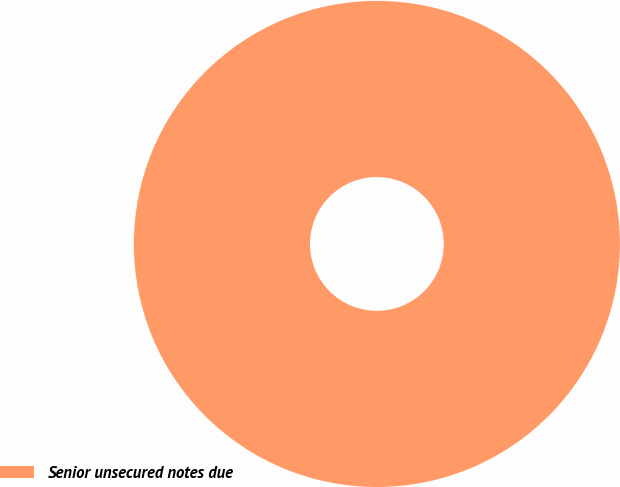Convert chart to OTSL. <chart><loc_0><loc_0><loc_500><loc_500><pie_chart><fcel>Senior unsecured notes due<nl><fcel>100.0%<nl></chart> 